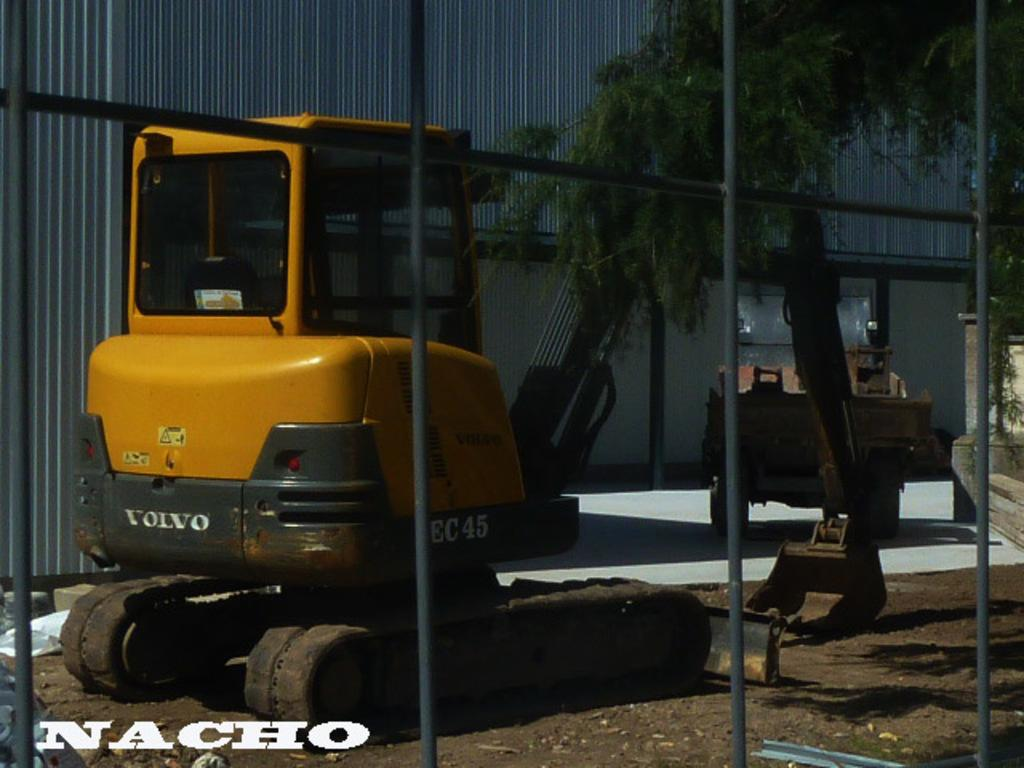What type of machinery can be seen on the ground in the image? There are excavators on the ground in the image. What is visible in the background of the image? There is a wall in the background of the image. What type of vegetation is on the right side of the image? There is a tree on the right side of the image. Can you describe the railway tracks in the image? There are no railway tracks present in the image; it features excavators, a wall, and a tree. How does the tree breathe in the image? Trees do not breathe in the same way as animals; they absorb carbon dioxide and release oxygen through a process called photosynthesis. However, this question is not relevant to the image, as it does not focus on the tree's biological processes. 